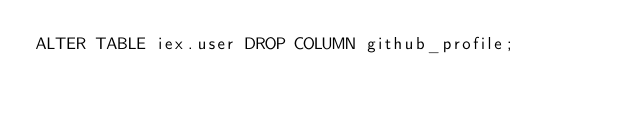<code> <loc_0><loc_0><loc_500><loc_500><_SQL_>ALTER TABLE iex.user DROP COLUMN github_profile;
</code> 